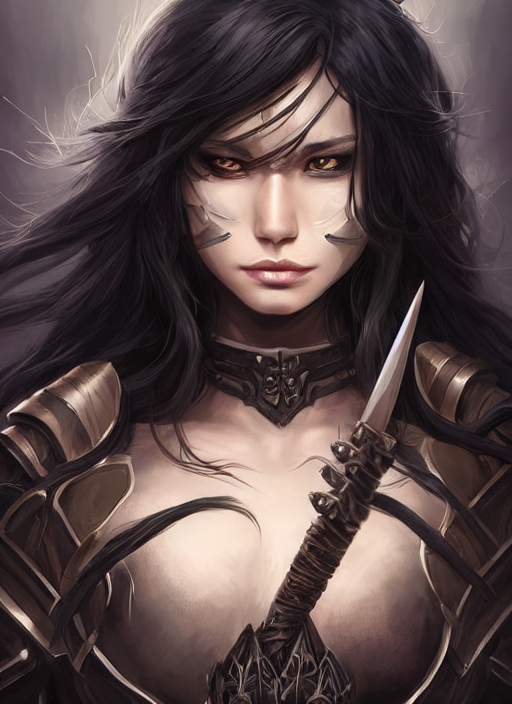Is the overall sharpness of this image above average? The sharpness of the image appears to be average; while the subject is in focus with good detail, the overall sharpness does not significantly exceed what's typically expected in high-resolution images. 